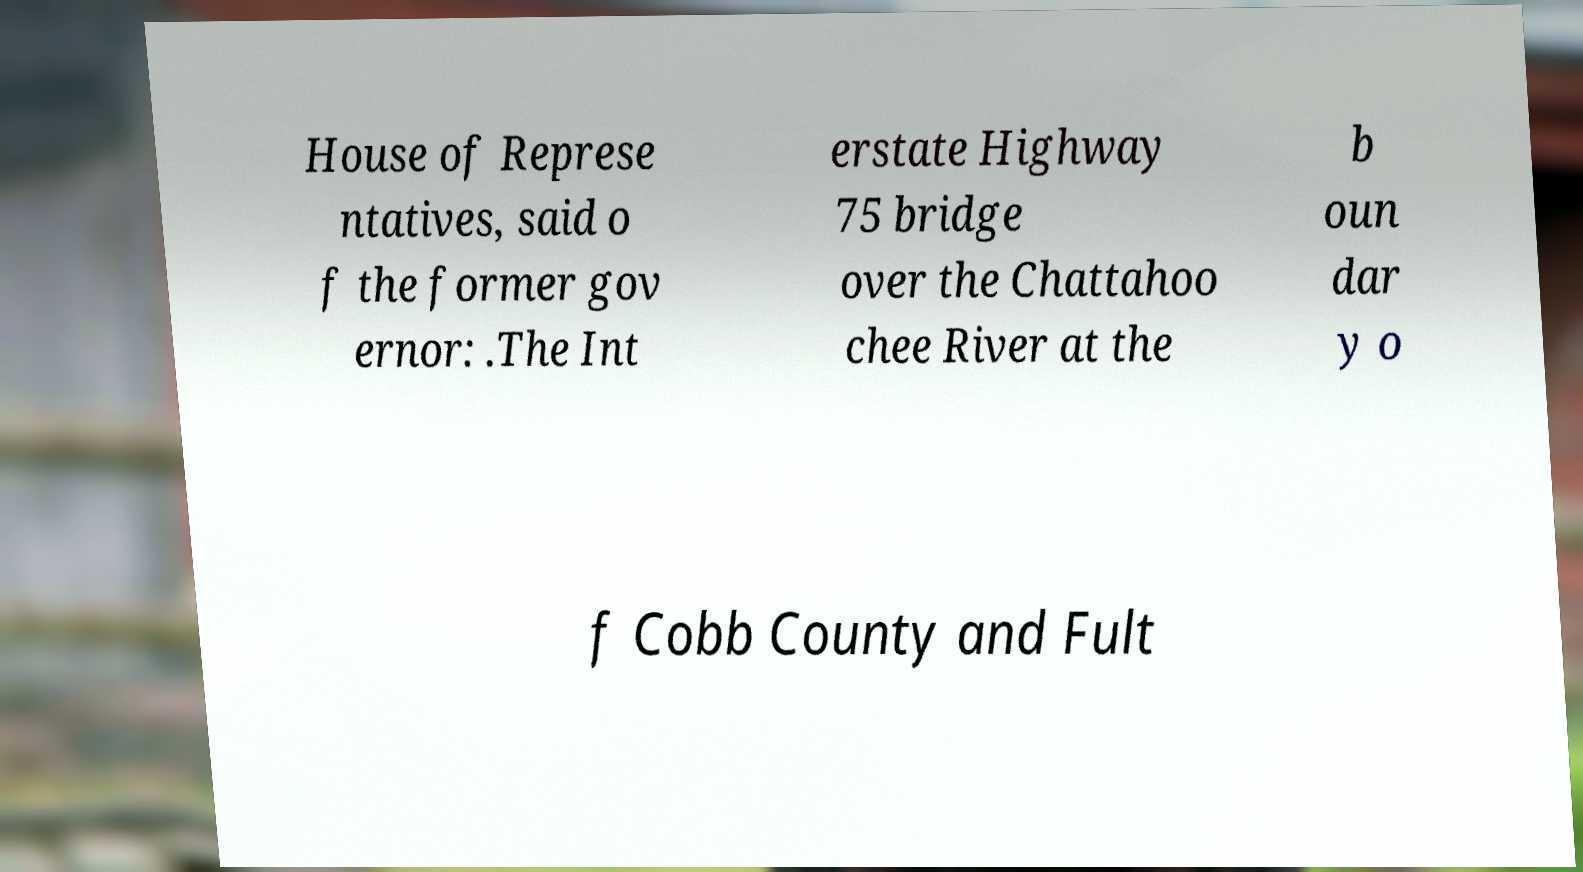There's text embedded in this image that I need extracted. Can you transcribe it verbatim? House of Represe ntatives, said o f the former gov ernor: .The Int erstate Highway 75 bridge over the Chattahoo chee River at the b oun dar y o f Cobb County and Fult 